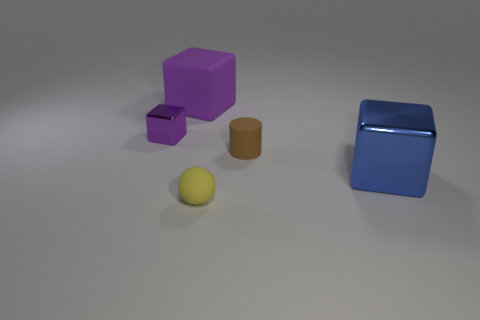Subtract all big cubes. How many cubes are left? 1 Add 4 small blue rubber cylinders. How many objects exist? 9 Subtract all blue cubes. How many cubes are left? 2 Subtract all gray spheres. How many purple blocks are left? 2 Subtract all cylinders. How many objects are left? 4 Subtract 2 cubes. How many cubes are left? 1 Subtract all green cubes. Subtract all purple cylinders. How many cubes are left? 3 Subtract all rubber objects. Subtract all shiny objects. How many objects are left? 0 Add 3 small purple objects. How many small purple objects are left? 4 Add 5 purple metal cylinders. How many purple metal cylinders exist? 5 